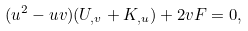Convert formula to latex. <formula><loc_0><loc_0><loc_500><loc_500>( u ^ { 2 } - u v ) ( U _ { , v } + K _ { , u } ) + 2 v F = 0 ,</formula> 